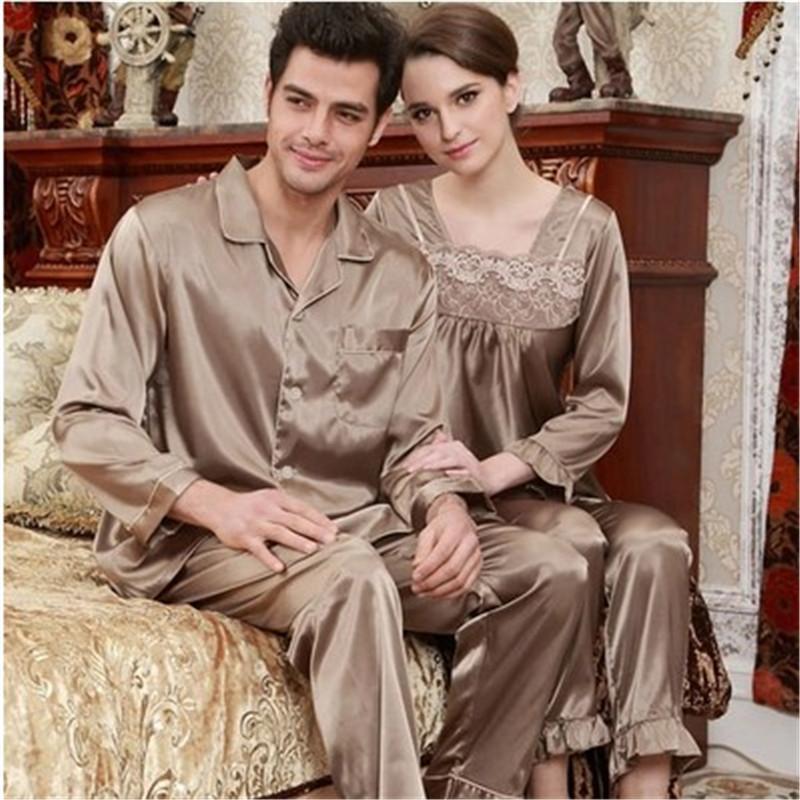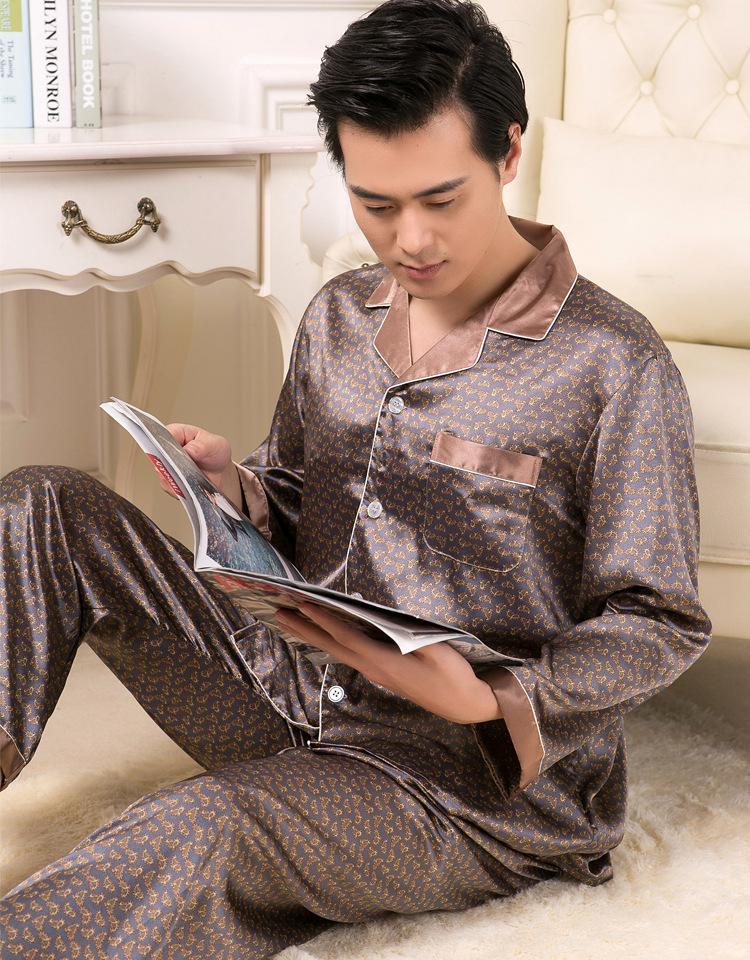The first image is the image on the left, the second image is the image on the right. Evaluate the accuracy of this statement regarding the images: "In one of the images, a man is wearing checkered pajamas.". Is it true? Answer yes or no. No. The first image is the image on the left, the second image is the image on the right. Considering the images on both sides, is "the man is holding something in his hands in the right pic" valid? Answer yes or no. Yes. 